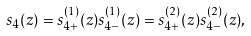Convert formula to latex. <formula><loc_0><loc_0><loc_500><loc_500>s _ { 4 } ( z ) = s _ { 4 + } ^ { ( 1 ) } ( z ) s _ { 4 - } ^ { ( 1 ) } ( z ) = s _ { 4 + } ^ { ( 2 ) } ( z ) s _ { 4 - } ^ { ( 2 ) } ( z ) ,</formula> 